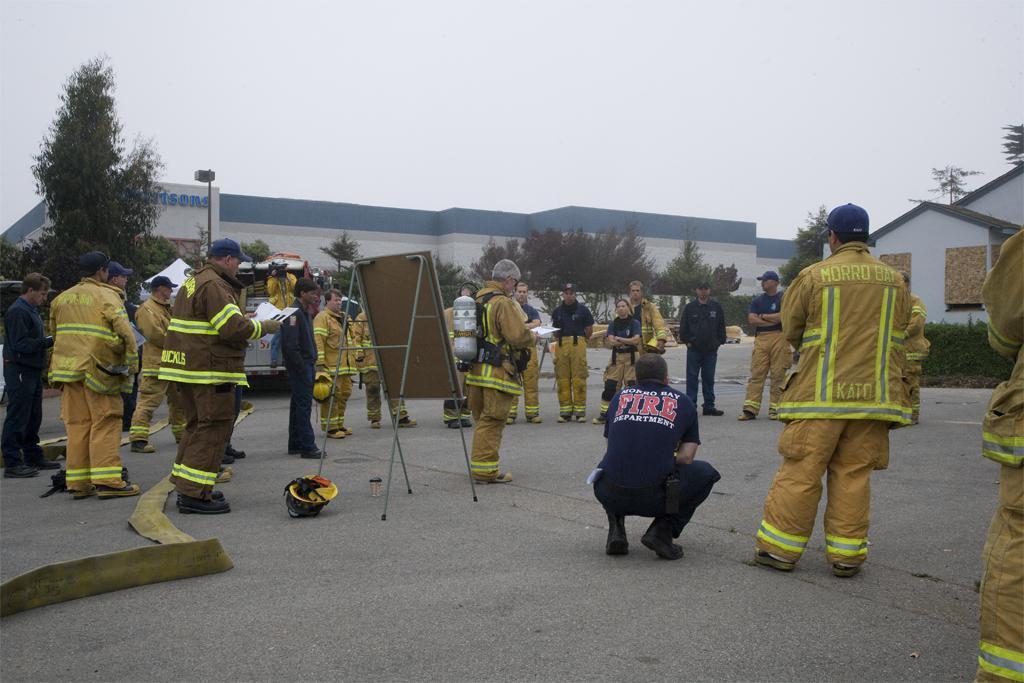Could you give a brief overview of what you see in this image? There are groups of people standing. This looks like a board with a stand. I can see a helmet, which is placed on the ground. These are the buildings and the trees. I can see the bushes. This looks like a pipe. Here is the sky. I can see a person sitting in squat position. 